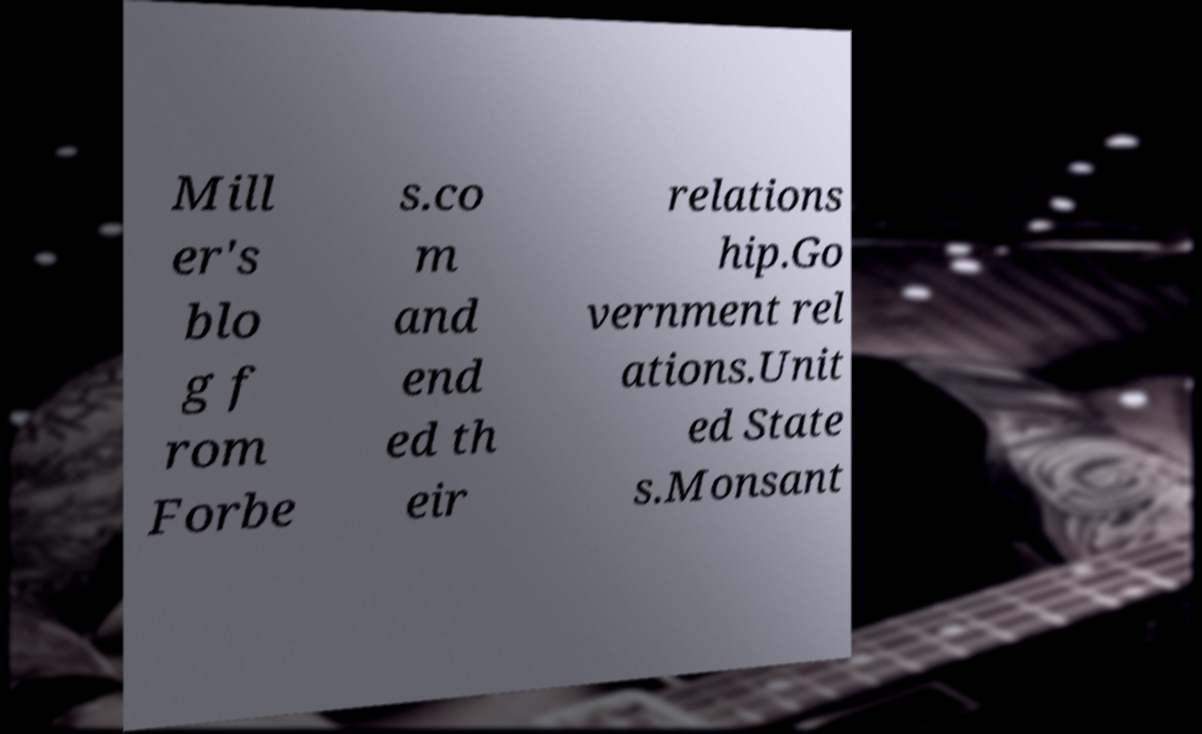Could you assist in decoding the text presented in this image and type it out clearly? Mill er's blo g f rom Forbe s.co m and end ed th eir relations hip.Go vernment rel ations.Unit ed State s.Monsant 